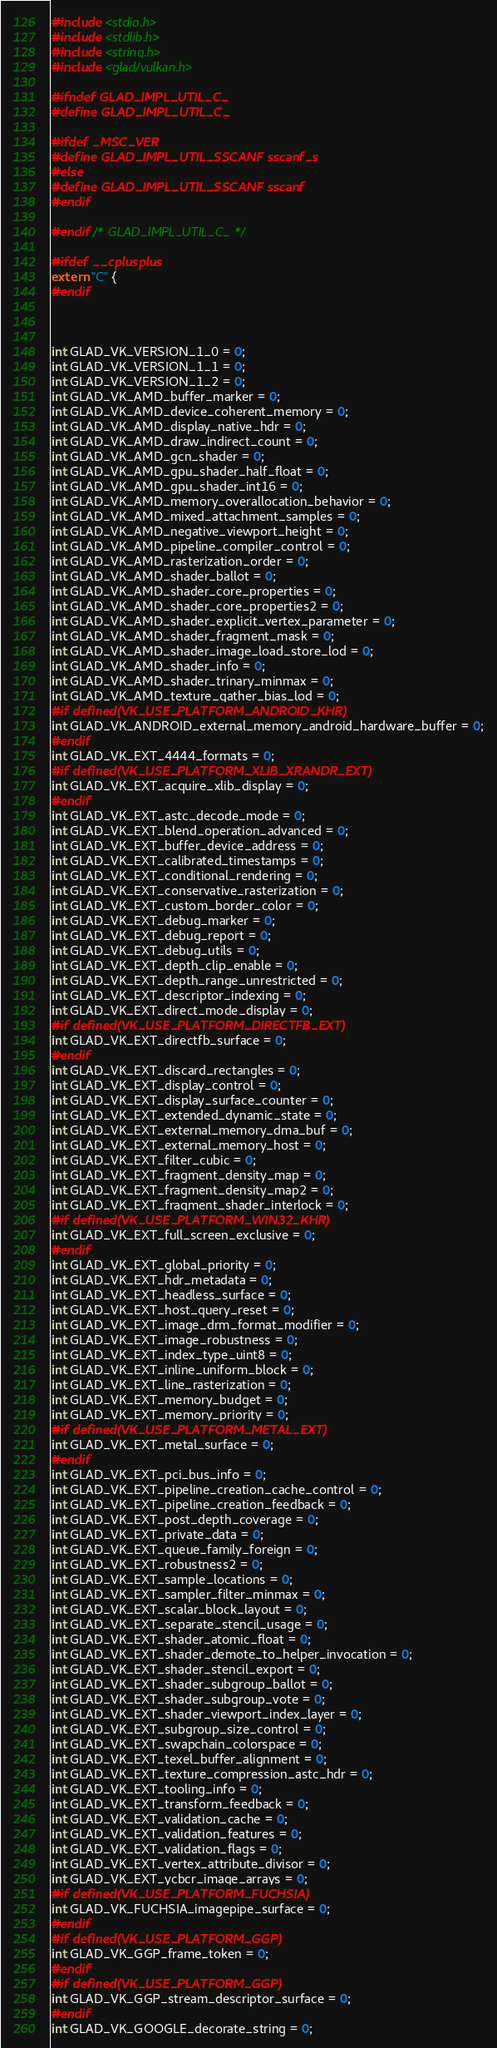<code> <loc_0><loc_0><loc_500><loc_500><_C_>#include <stdio.h>
#include <stdlib.h>
#include <string.h>
#include <glad/vulkan.h>

#ifndef GLAD_IMPL_UTIL_C_
#define GLAD_IMPL_UTIL_C_

#ifdef _MSC_VER
#define GLAD_IMPL_UTIL_SSCANF sscanf_s
#else
#define GLAD_IMPL_UTIL_SSCANF sscanf
#endif

#endif /* GLAD_IMPL_UTIL_C_ */

#ifdef __cplusplus
extern "C" {
#endif



int GLAD_VK_VERSION_1_0 = 0;
int GLAD_VK_VERSION_1_1 = 0;
int GLAD_VK_VERSION_1_2 = 0;
int GLAD_VK_AMD_buffer_marker = 0;
int GLAD_VK_AMD_device_coherent_memory = 0;
int GLAD_VK_AMD_display_native_hdr = 0;
int GLAD_VK_AMD_draw_indirect_count = 0;
int GLAD_VK_AMD_gcn_shader = 0;
int GLAD_VK_AMD_gpu_shader_half_float = 0;
int GLAD_VK_AMD_gpu_shader_int16 = 0;
int GLAD_VK_AMD_memory_overallocation_behavior = 0;
int GLAD_VK_AMD_mixed_attachment_samples = 0;
int GLAD_VK_AMD_negative_viewport_height = 0;
int GLAD_VK_AMD_pipeline_compiler_control = 0;
int GLAD_VK_AMD_rasterization_order = 0;
int GLAD_VK_AMD_shader_ballot = 0;
int GLAD_VK_AMD_shader_core_properties = 0;
int GLAD_VK_AMD_shader_core_properties2 = 0;
int GLAD_VK_AMD_shader_explicit_vertex_parameter = 0;
int GLAD_VK_AMD_shader_fragment_mask = 0;
int GLAD_VK_AMD_shader_image_load_store_lod = 0;
int GLAD_VK_AMD_shader_info = 0;
int GLAD_VK_AMD_shader_trinary_minmax = 0;
int GLAD_VK_AMD_texture_gather_bias_lod = 0;
#if defined(VK_USE_PLATFORM_ANDROID_KHR)
int GLAD_VK_ANDROID_external_memory_android_hardware_buffer = 0;
#endif
int GLAD_VK_EXT_4444_formats = 0;
#if defined(VK_USE_PLATFORM_XLIB_XRANDR_EXT)
int GLAD_VK_EXT_acquire_xlib_display = 0;
#endif
int GLAD_VK_EXT_astc_decode_mode = 0;
int GLAD_VK_EXT_blend_operation_advanced = 0;
int GLAD_VK_EXT_buffer_device_address = 0;
int GLAD_VK_EXT_calibrated_timestamps = 0;
int GLAD_VK_EXT_conditional_rendering = 0;
int GLAD_VK_EXT_conservative_rasterization = 0;
int GLAD_VK_EXT_custom_border_color = 0;
int GLAD_VK_EXT_debug_marker = 0;
int GLAD_VK_EXT_debug_report = 0;
int GLAD_VK_EXT_debug_utils = 0;
int GLAD_VK_EXT_depth_clip_enable = 0;
int GLAD_VK_EXT_depth_range_unrestricted = 0;
int GLAD_VK_EXT_descriptor_indexing = 0;
int GLAD_VK_EXT_direct_mode_display = 0;
#if defined(VK_USE_PLATFORM_DIRECTFB_EXT)
int GLAD_VK_EXT_directfb_surface = 0;
#endif
int GLAD_VK_EXT_discard_rectangles = 0;
int GLAD_VK_EXT_display_control = 0;
int GLAD_VK_EXT_display_surface_counter = 0;
int GLAD_VK_EXT_extended_dynamic_state = 0;
int GLAD_VK_EXT_external_memory_dma_buf = 0;
int GLAD_VK_EXT_external_memory_host = 0;
int GLAD_VK_EXT_filter_cubic = 0;
int GLAD_VK_EXT_fragment_density_map = 0;
int GLAD_VK_EXT_fragment_density_map2 = 0;
int GLAD_VK_EXT_fragment_shader_interlock = 0;
#if defined(VK_USE_PLATFORM_WIN32_KHR)
int GLAD_VK_EXT_full_screen_exclusive = 0;
#endif
int GLAD_VK_EXT_global_priority = 0;
int GLAD_VK_EXT_hdr_metadata = 0;
int GLAD_VK_EXT_headless_surface = 0;
int GLAD_VK_EXT_host_query_reset = 0;
int GLAD_VK_EXT_image_drm_format_modifier = 0;
int GLAD_VK_EXT_image_robustness = 0;
int GLAD_VK_EXT_index_type_uint8 = 0;
int GLAD_VK_EXT_inline_uniform_block = 0;
int GLAD_VK_EXT_line_rasterization = 0;
int GLAD_VK_EXT_memory_budget = 0;
int GLAD_VK_EXT_memory_priority = 0;
#if defined(VK_USE_PLATFORM_METAL_EXT)
int GLAD_VK_EXT_metal_surface = 0;
#endif
int GLAD_VK_EXT_pci_bus_info = 0;
int GLAD_VK_EXT_pipeline_creation_cache_control = 0;
int GLAD_VK_EXT_pipeline_creation_feedback = 0;
int GLAD_VK_EXT_post_depth_coverage = 0;
int GLAD_VK_EXT_private_data = 0;
int GLAD_VK_EXT_queue_family_foreign = 0;
int GLAD_VK_EXT_robustness2 = 0;
int GLAD_VK_EXT_sample_locations = 0;
int GLAD_VK_EXT_sampler_filter_minmax = 0;
int GLAD_VK_EXT_scalar_block_layout = 0;
int GLAD_VK_EXT_separate_stencil_usage = 0;
int GLAD_VK_EXT_shader_atomic_float = 0;
int GLAD_VK_EXT_shader_demote_to_helper_invocation = 0;
int GLAD_VK_EXT_shader_stencil_export = 0;
int GLAD_VK_EXT_shader_subgroup_ballot = 0;
int GLAD_VK_EXT_shader_subgroup_vote = 0;
int GLAD_VK_EXT_shader_viewport_index_layer = 0;
int GLAD_VK_EXT_subgroup_size_control = 0;
int GLAD_VK_EXT_swapchain_colorspace = 0;
int GLAD_VK_EXT_texel_buffer_alignment = 0;
int GLAD_VK_EXT_texture_compression_astc_hdr = 0;
int GLAD_VK_EXT_tooling_info = 0;
int GLAD_VK_EXT_transform_feedback = 0;
int GLAD_VK_EXT_validation_cache = 0;
int GLAD_VK_EXT_validation_features = 0;
int GLAD_VK_EXT_validation_flags = 0;
int GLAD_VK_EXT_vertex_attribute_divisor = 0;
int GLAD_VK_EXT_ycbcr_image_arrays = 0;
#if defined(VK_USE_PLATFORM_FUCHSIA)
int GLAD_VK_FUCHSIA_imagepipe_surface = 0;
#endif
#if defined(VK_USE_PLATFORM_GGP)
int GLAD_VK_GGP_frame_token = 0;
#endif
#if defined(VK_USE_PLATFORM_GGP)
int GLAD_VK_GGP_stream_descriptor_surface = 0;
#endif
int GLAD_VK_GOOGLE_decorate_string = 0;</code> 